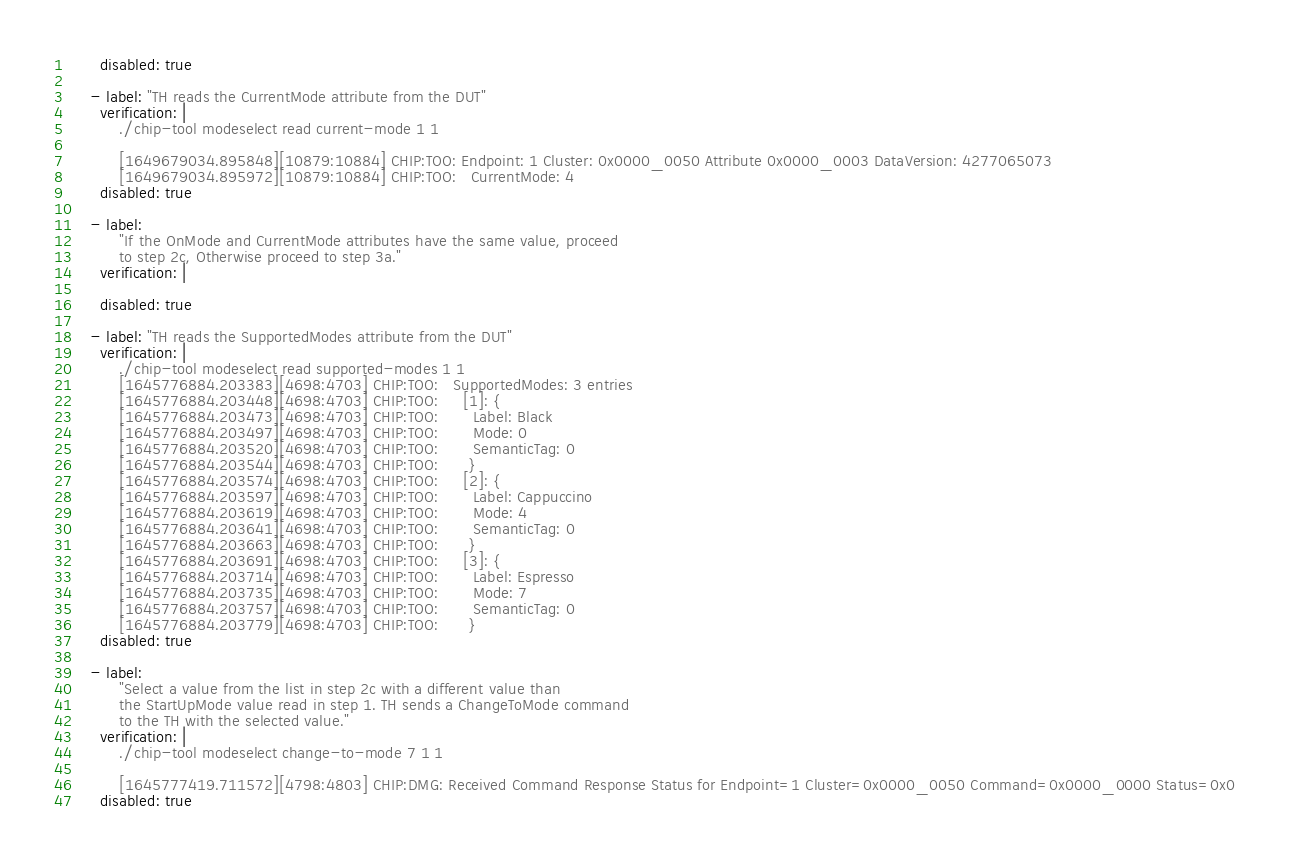Convert code to text. <code><loc_0><loc_0><loc_500><loc_500><_YAML_>      disabled: true

    - label: "TH reads the CurrentMode attribute from the DUT"
      verification: |
          ./chip-tool modeselect read current-mode 1 1

          [1649679034.895848][10879:10884] CHIP:TOO: Endpoint: 1 Cluster: 0x0000_0050 Attribute 0x0000_0003 DataVersion: 4277065073
          [1649679034.895972][10879:10884] CHIP:TOO:   CurrentMode: 4
      disabled: true

    - label:
          "If the OnMode and CurrentMode attributes have the same value, proceed
          to step 2c, Otherwise proceed to step 3a."
      verification: |

      disabled: true

    - label: "TH reads the SupportedModes attribute from the DUT"
      verification: |
          ./chip-tool modeselect read supported-modes 1 1
          [1645776884.203383][4698:4703] CHIP:TOO:   SupportedModes: 3 entries
          [1645776884.203448][4698:4703] CHIP:TOO:     [1]: {
          [1645776884.203473][4698:4703] CHIP:TOO:       Label: Black
          [1645776884.203497][4698:4703] CHIP:TOO:       Mode: 0
          [1645776884.203520][4698:4703] CHIP:TOO:       SemanticTag: 0
          [1645776884.203544][4698:4703] CHIP:TOO:      }
          [1645776884.203574][4698:4703] CHIP:TOO:     [2]: {
          [1645776884.203597][4698:4703] CHIP:TOO:       Label: Cappuccino
          [1645776884.203619][4698:4703] CHIP:TOO:       Mode: 4
          [1645776884.203641][4698:4703] CHIP:TOO:       SemanticTag: 0
          [1645776884.203663][4698:4703] CHIP:TOO:      }
          [1645776884.203691][4698:4703] CHIP:TOO:     [3]: {
          [1645776884.203714][4698:4703] CHIP:TOO:       Label: Espresso
          [1645776884.203735][4698:4703] CHIP:TOO:       Mode: 7
          [1645776884.203757][4698:4703] CHIP:TOO:       SemanticTag: 0
          [1645776884.203779][4698:4703] CHIP:TOO:      }
      disabled: true

    - label:
          "Select a value from the list in step 2c with a different value than
          the StartUpMode value read in step 1. TH sends a ChangeToMode command
          to the TH with the selected value."
      verification: |
          ./chip-tool modeselect change-to-mode 7 1 1

          [1645777419.711572][4798:4803] CHIP:DMG: Received Command Response Status for Endpoint=1 Cluster=0x0000_0050 Command=0x0000_0000 Status=0x0
      disabled: true
</code> 